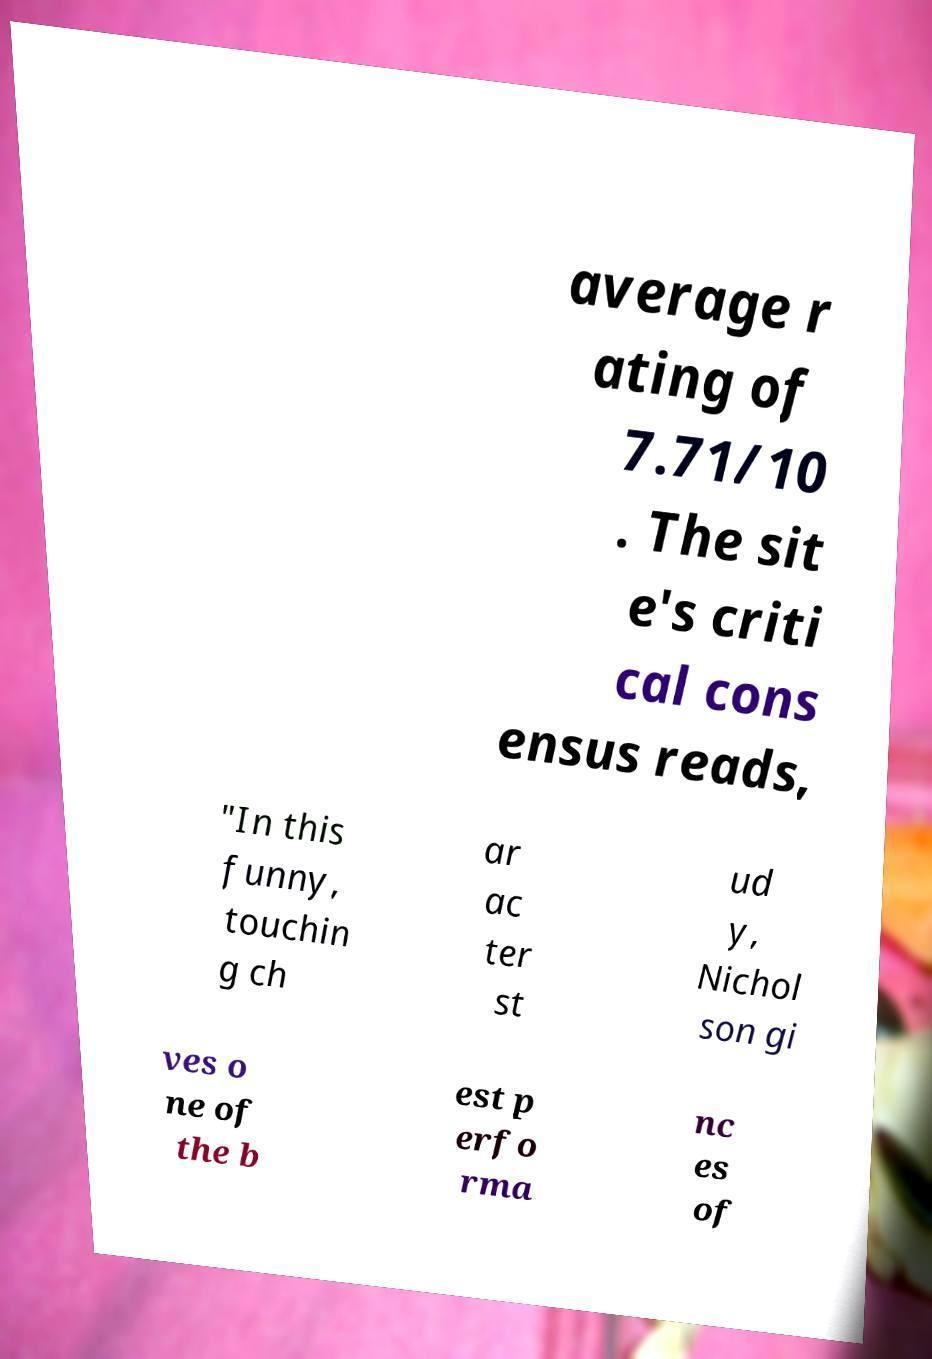Please read and relay the text visible in this image. What does it say? average r ating of 7.71/10 . The sit e's criti cal cons ensus reads, "In this funny, touchin g ch ar ac ter st ud y, Nichol son gi ves o ne of the b est p erfo rma nc es of 